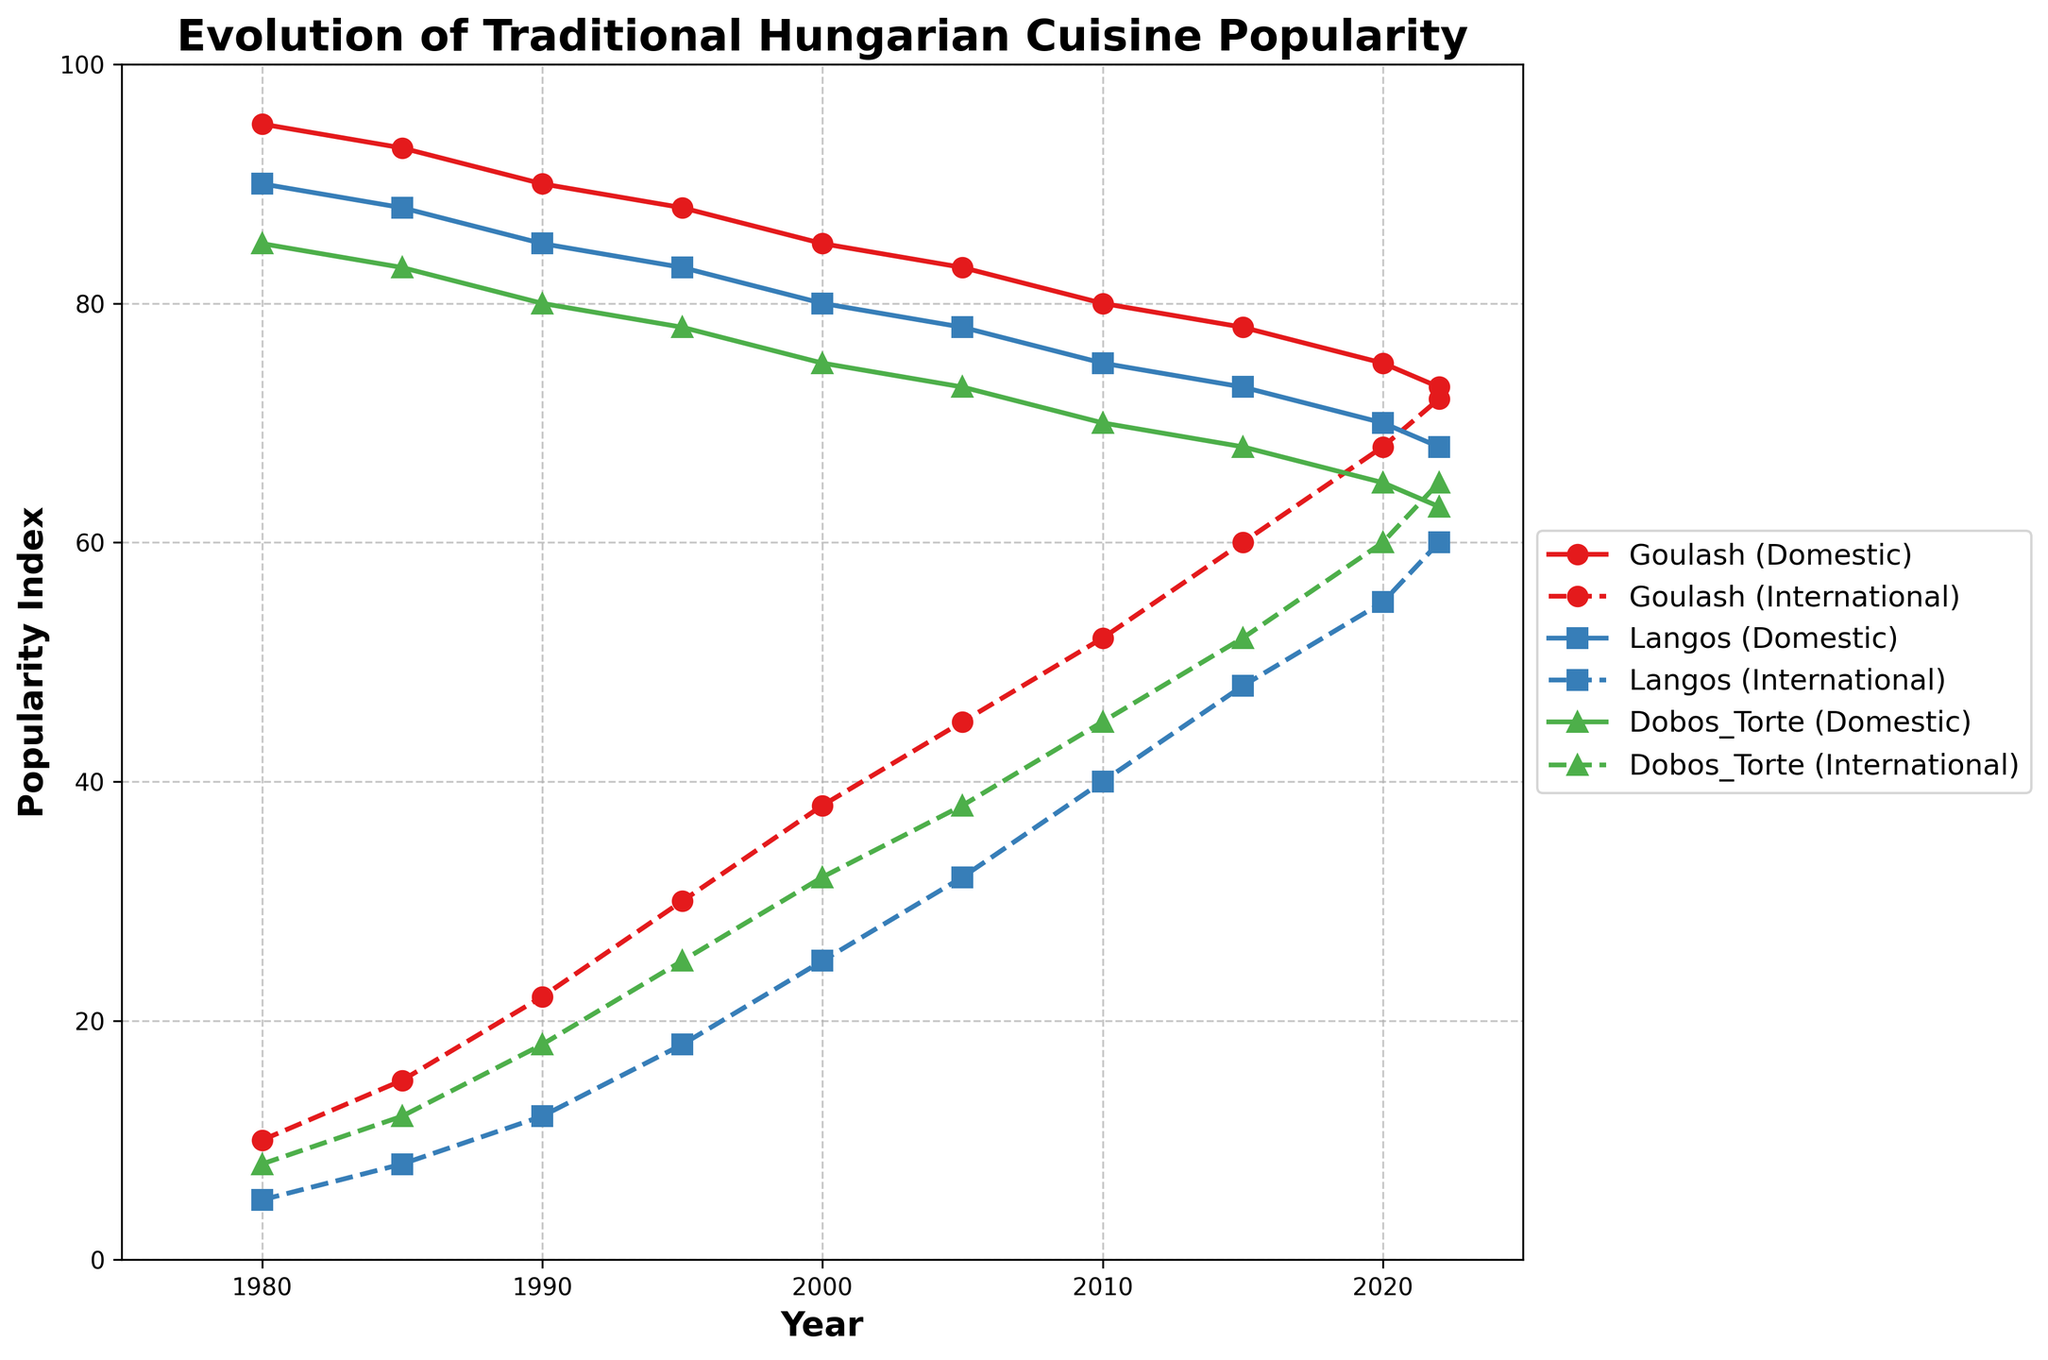Which dish experienced the greatest increase in international popularity from 1980 to 2022? To find the dish with the greatest increase in international popularity, we need to subtract the 1980 international popularity index from the 2022 value for each dish. Comparing these increases: Goulash (72-10=62), Langos (60-5=55), and Dobos Torte (65-8=57), Goulash has the greatest increase of 62.
Answer: Goulash What is the trend in domestic popularity for Langos from 1980 to 2022? To identify the trend, observe the line for Langos (Domestic) over the years. The popularity index decreases consistently from 90 in 1980 to 68 in 2022.
Answer: Decreasing Which dish maintained the highest domestic popularity throughout the entire period? To determine this, we compare the domestic popularity indices of Goulash, Langos, and Dobos Torte across all years. Goulash consistently retains higher values compared to the other dishes.
Answer: Goulash Compare the international popularity of Dobos Torte in 1990 and 2000. Which year had a higher popularity, and by how much? Check the international popularity values for Dobos Torte in 1990 (18) and 2000 (32). 2000 is higher, and the difference is 32 - 18 = 14.
Answer: 2000, by 14 In which year did the international popularity of Langos surpass the domestic popularity of Goulash for the first time? Identify the year where the Langos (International) line first crosses above the Goulash (Domestic) line. This occurs around 2020, where Langos' international popularity (55) is higher than Goulash's domestic (75).
Answer: 2020 What is the average domestic popularity of Dobos Torte across the years 1980, 1990, 2000, and 2020? Sum the domestic popularity values for Dobos Torte in these years (85+80+75+65) and divide by 4. Calculation: (85+80+75+65)/4 = 305/4 = 76.25.
Answer: 76.25 How does the steepness of the slope for Goulash's international popularity change between 1980-1990 and 2010-2022? The slope indicates the rate of change. Calculate the change per year for each period. For 1980-1990: (22-10)/10=1.2 per year. For 2010-2022: (72-52)/12=1.67 per year. The slope increases in the second period.
Answer: Steeper from 2010-2022 Which year shows the biggest difference between domestic and international popularity for Dobos Torte? Subtract the international popularity from the domestic for each year and find the largest difference. 1980 has the largest difference: 85 (Domestic) - 8 (International) = 77.
Answer: 1980 What's the combined international popularity of Goulash and Langos in 2005? Sum the international popularity indices of Goulash (45) and Langos (32) for the year 2005. Calculation: 45 + 32 = 77.
Answer: 77 